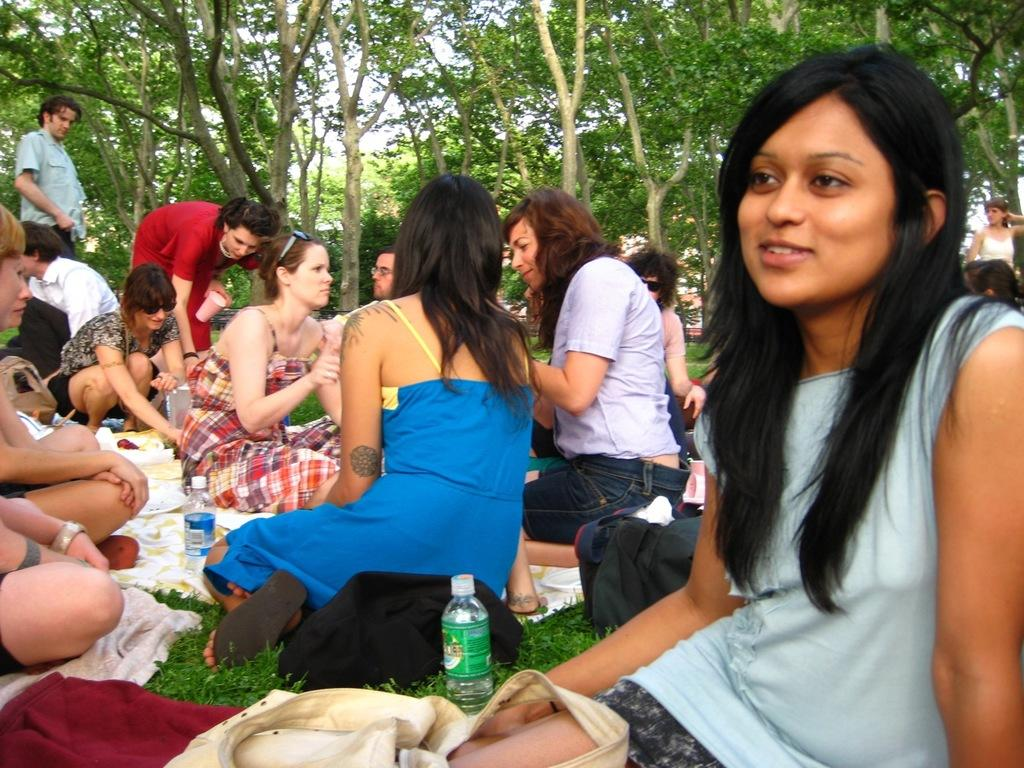What are the people in the image doing? There is a group of people sitting on the ground in the image. What objects can be seen near the people? There are bottles visible in the image. What type of natural environment is present in the image? There are trees present in the image. How many thumbs can be seen exchanging bottles in the image? There is no exchange of bottles or thumbs visible in the image; it only shows a group of people sitting on the ground and bottles nearby. 